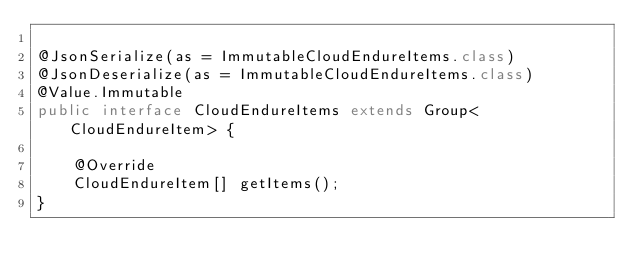Convert code to text. <code><loc_0><loc_0><loc_500><loc_500><_Java_>
@JsonSerialize(as = ImmutableCloudEndureItems.class)
@JsonDeserialize(as = ImmutableCloudEndureItems.class)
@Value.Immutable
public interface CloudEndureItems extends Group<CloudEndureItem> {

    @Override
    CloudEndureItem[] getItems();
}
</code> 